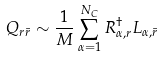Convert formula to latex. <formula><loc_0><loc_0><loc_500><loc_500>Q _ { r { \bar { r } } } \sim \frac { 1 } { M } \sum _ { \alpha = 1 } ^ { N _ { C } } R ^ { \dagger } _ { \alpha , r } L _ { \alpha , { \bar { r } } }</formula> 